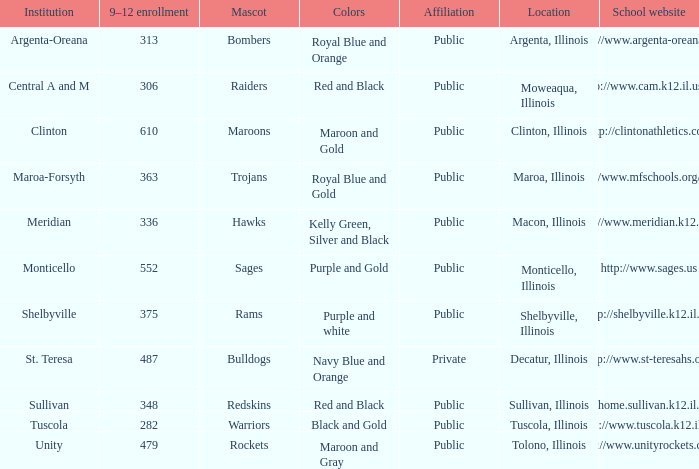What's the name of the city or town of the school that operates the http://www.mfschools.org/high/ website? Maroa-Forsyth. I'm looking to parse the entire table for insights. Could you assist me with that? {'header': ['Institution', '9–12 enrollment', 'Mascot', 'Colors', 'Affiliation', 'Location', 'School website'], 'rows': [['Argenta-Oreana', '313', 'Bombers', 'Royal Blue and Orange', 'Public', 'Argenta, Illinois', 'http://www.argenta-oreana.org'], ['Central A and M', '306', 'Raiders', 'Red and Black', 'Public', 'Moweaqua, Illinois', 'http://www.cam.k12.il.us/hs'], ['Clinton', '610', 'Maroons', 'Maroon and Gold', 'Public', 'Clinton, Illinois', 'http://clintonathletics.com'], ['Maroa-Forsyth', '363', 'Trojans', 'Royal Blue and Gold', 'Public', 'Maroa, Illinois', 'http://www.mfschools.org/high/'], ['Meridian', '336', 'Hawks', 'Kelly Green, Silver and Black', 'Public', 'Macon, Illinois', 'http://www.meridian.k12.il.us/'], ['Monticello', '552', 'Sages', 'Purple and Gold', 'Public', 'Monticello, Illinois', 'http://www.sages.us'], ['Shelbyville', '375', 'Rams', 'Purple and white', 'Public', 'Shelbyville, Illinois', 'http://shelbyville.k12.il.us/'], ['St. Teresa', '487', 'Bulldogs', 'Navy Blue and Orange', 'Private', 'Decatur, Illinois', 'http://www.st-teresahs.org/'], ['Sullivan', '348', 'Redskins', 'Red and Black', 'Public', 'Sullivan, Illinois', 'http://home.sullivan.k12.il.us/shs'], ['Tuscola', '282', 'Warriors', 'Black and Gold', 'Public', 'Tuscola, Illinois', 'http://www.tuscola.k12.il.us/'], ['Unity', '479', 'Rockets', 'Maroon and Gray', 'Public', 'Tolono, Illinois', 'http://www.unityrockets.com/']]} 